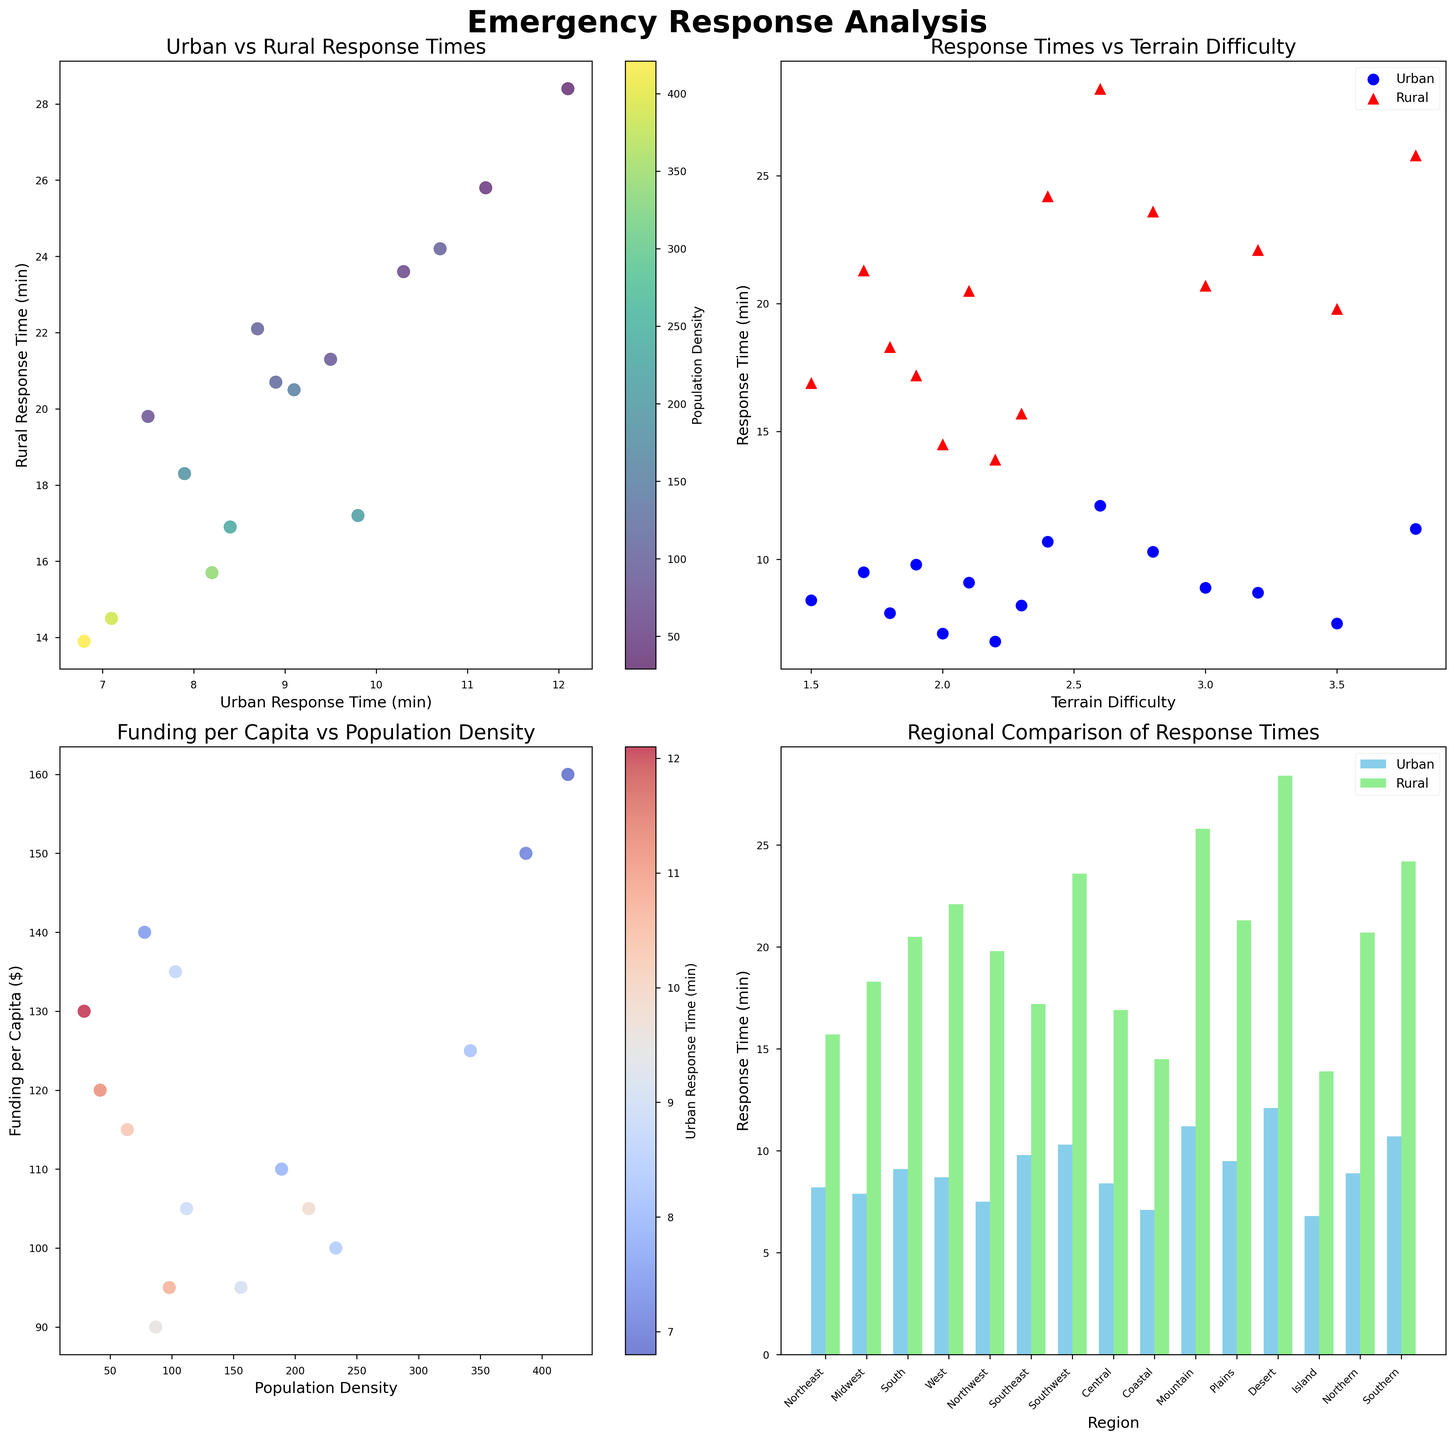what's the average response time in urban regions? We need to sum all urban response times and divide by the number of regions. The urban response times are (8.2 + 7.9 + 9.1 + 8.7 + 7.5 + 9.8 + 10.3 + 8.4 + 7.1 + 11.2 + 9.5 + 12.1 + 6.8 + 8.9 + 10.7). Sum = 136.2. Number of regions = 15. Average = 136.2 / 15 = 9.08
Answer: 9.08 Which region has the highest rural response time? We look for the tallest bar in the "Rural Response Time" category in the Regional Comparison subplot. The region with the highest bar is Desert with a rural response time of 28.4 minutes
Answer: Desert Is there a relationship between terrain difficulty and response times? We observe the scatter plot for Response Times vs Terrain Difficulty. If there is a clear upward or downward trend for urban or rural data points as terrain difficulty increases, we can infer a relationship. Here, both urban and rural response times generally increase as terrain difficulty increases.
Answer: Yes, both response times increase How does the response time differ between urban and rural areas in the Northern region? In the Regional Comparison subplot, check the bars for the Northern region. Urban response time is 8.9, and rural response time is 20.7. Difference = 20.7 - 8.9 = 11.8
Answer: 11.8 What is the range of funding per capita across all regions? We need to find the difference between the maximum and minimum funding per capita from the dataset. The maximum funding per capita is 160 (Island), and the minimum is 90 (Plains). Range = 160 - 90
Answer: 70 Does higher population density correlate with lower urban response times? Refer to the subplot showing 'Funding per Capita vs Population Density' with urban response time as color. Regions with higher population densities (darker blue) generally show lower urban response times.
Answer: Yes Which region has both relatively high population density and high urban response time? Cross-reference the 'Funding per Capita vs Population Density' subplot (higher density) and the 'Regional Comparison' subplot (higher response time). The Southeast region stands out with both high population density and high urban response time (9.8).
Answer: Southeast Is there a significant visual difference of response times between Coastal and Southern regions? From the Regional Comparison subplot, compare the bar heights. Coastal has urban: 7.1 and rural: 14.5. Southern has urban: 10.7 and rural: 24.2. These differences are visually significant.
Answer: Yes Which region has the lowest urban response time, and what is it? Check the lowest bar in the urban category of the Regional Comparison subplot. The lowest is Island with 6.8 minutes.
Answer: Island, 6.8 